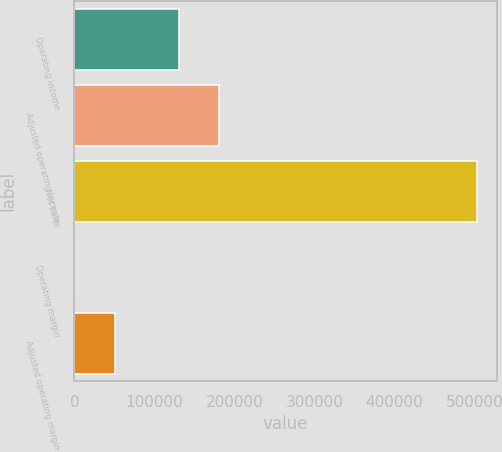Convert chart. <chart><loc_0><loc_0><loc_500><loc_500><bar_chart><fcel>Operating income<fcel>Adjusted operating income<fcel>Net sales<fcel>Operating margin<fcel>Adjusted operating margin<nl><fcel>130494<fcel>180766<fcel>502749<fcel>26<fcel>50298.3<nl></chart> 